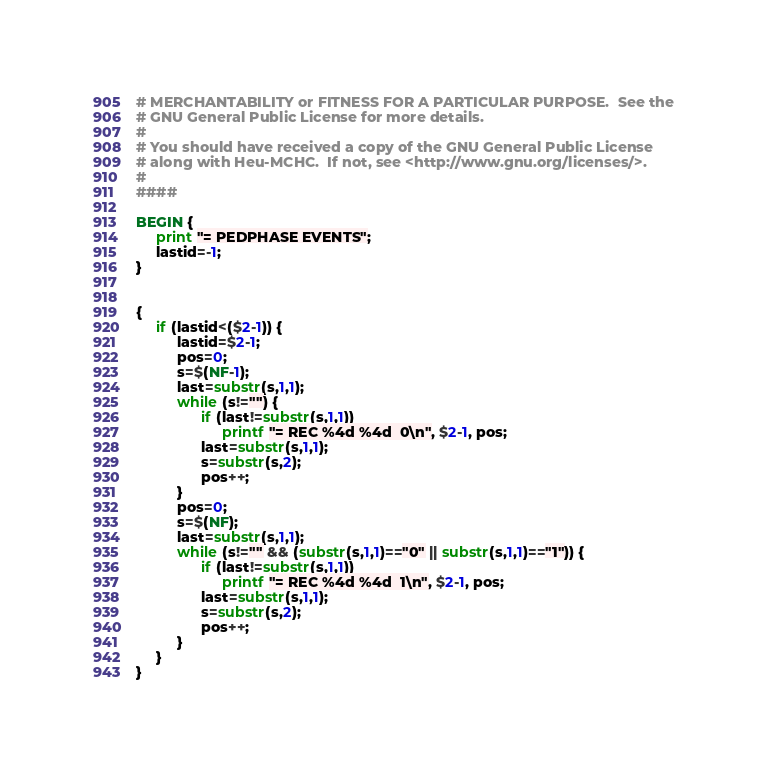<code> <loc_0><loc_0><loc_500><loc_500><_Awk_># MERCHANTABILITY or FITNESS FOR A PARTICULAR PURPOSE.  See the
# GNU General Public License for more details.
#
# You should have received a copy of the GNU General Public License
# along with Heu-MCHC.  If not, see <http://www.gnu.org/licenses/>.
#
####

BEGIN {
	 print "= PEDPHASE EVENTS";
	 lastid=-1;
}


{
	 if (lastid<($2-1)) {
		  lastid=$2-1;
		  pos=0;
		  s=$(NF-1);
		  last=substr(s,1,1);
		  while (s!="") {
				if (last!=substr(s,1,1))
					 printf "= REC %4d %4d  0\n", $2-1, pos;
				last=substr(s,1,1);
				s=substr(s,2);
				pos++;
		  }
		  pos=0;
		  s=$(NF);
		  last=substr(s,1,1);
		  while (s!="" && (substr(s,1,1)=="0" || substr(s,1,1)=="1")) {
				if (last!=substr(s,1,1))
					 printf "= REC %4d %4d  1\n", $2-1, pos;
				last=substr(s,1,1);
				s=substr(s,2);
				pos++;
		  }
	 }
}
</code> 